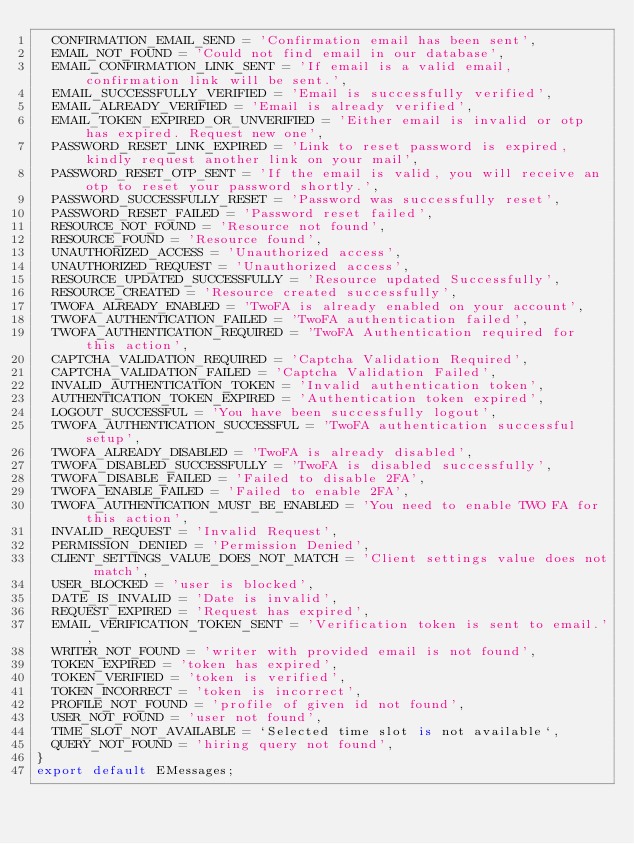<code> <loc_0><loc_0><loc_500><loc_500><_TypeScript_>  CONFIRMATION_EMAIL_SEND = 'Confirmation email has been sent',
  EMAIL_NOT_FOUND = 'Could not find email in our database',
  EMAIL_CONFIRMATION_LINK_SENT = 'If email is a valid email, confirmation link will be sent.',
  EMAIL_SUCCESSFULLY_VERIFIED = 'Email is successfully verified',
  EMAIL_ALREADY_VERIFIED = 'Email is already verified',
  EMAIL_TOKEN_EXPIRED_OR_UNVERIFIED = 'Either email is invalid or otp has expired. Request new one',
  PASSWORD_RESET_LINK_EXPIRED = 'Link to reset password is expired, kindly request another link on your mail',
  PASSWORD_RESET_OTP_SENT = 'If the email is valid, you will receive an otp to reset your password shortly.',
  PASSWORD_SUCCESSFULLY_RESET = 'Password was successfully reset',
  PASSWORD_RESET_FAILED = 'Password reset failed',
  RESOURCE_NOT_FOUND = 'Resource not found',
  RESOURCE_FOUND = 'Resource found',
  UNAUTHORIZED_ACCESS = 'Unauthorized access',
  UNAUTHORIZED_REQUEST = 'Unauthorized access',
  RESOURCE_UPDATED_SUCCESSFULLY = 'Resource updated Successfully',
  RESOURCE_CREATED = 'Resource created successfully',
  TWOFA_ALREADY_ENABLED = 'TwoFA is already enabled on your account',
  TWOFA_AUTHENTICATION_FAILED = 'TwoFA authentication failed',
  TWOFA_AUTHENTICATION_REQUIRED = 'TwoFA Authentication required for this action',
  CAPTCHA_VALIDATION_REQUIRED = 'Captcha Validation Required',
  CAPTCHA_VALIDATION_FAILED = 'Captcha Validation Failed',
  INVALID_AUTHENTICATION_TOKEN = 'Invalid authentication token',
  AUTHENTICATION_TOKEN_EXPIRED = 'Authentication token expired',
  LOGOUT_SUCCESSFUL = 'You have been successfully logout',
  TWOFA_AUTHENTICATION_SUCCESSFUL = 'TwoFA authentication successful setup',
  TWOFA_ALREADY_DISABLED = 'TwoFA is already disabled',
  TWOFA_DISABLED_SUCCESSFULLY = 'TwoFA is disabled successfully',
  TWOFA_DISABLE_FAILED = 'Failed to disable 2FA',
  TWOFA_ENABLE_FAILED = 'Failed to enable 2FA',
  TWOFA_AUTHENTICATION_MUST_BE_ENABLED = 'You need to enable TWO FA for this action',
  INVALID_REQUEST = 'Invalid Request',
  PERMISSION_DENIED = 'Permission Denied',
  CLIENT_SETTINGS_VALUE_DOES_NOT_MATCH = 'Client settings value does not match',
  USER_BLOCKED = 'user is blocked',
  DATE_IS_INVALID = 'Date is invalid',
  REQUEST_EXPIRED = 'Request has expired',
  EMAIL_VERIFICATION_TOKEN_SENT = 'Verification token is sent to email.',
  WRITER_NOT_FOUND = 'writer with provided email is not found',
  TOKEN_EXPIRED = 'token has expired',
  TOKEN_VERIFIED = 'token is verified',
  TOKEN_INCORRECT = 'token is incorrect',
  PROFILE_NOT_FOUND = 'profile of given id not found',
  USER_NOT_FOUND = 'user not found',
  TIME_SLOT_NOT_AVAILABLE = `Selected time slot is not available`,
  QUERY_NOT_FOUND = 'hiring query not found',
}
export default EMessages;</code> 